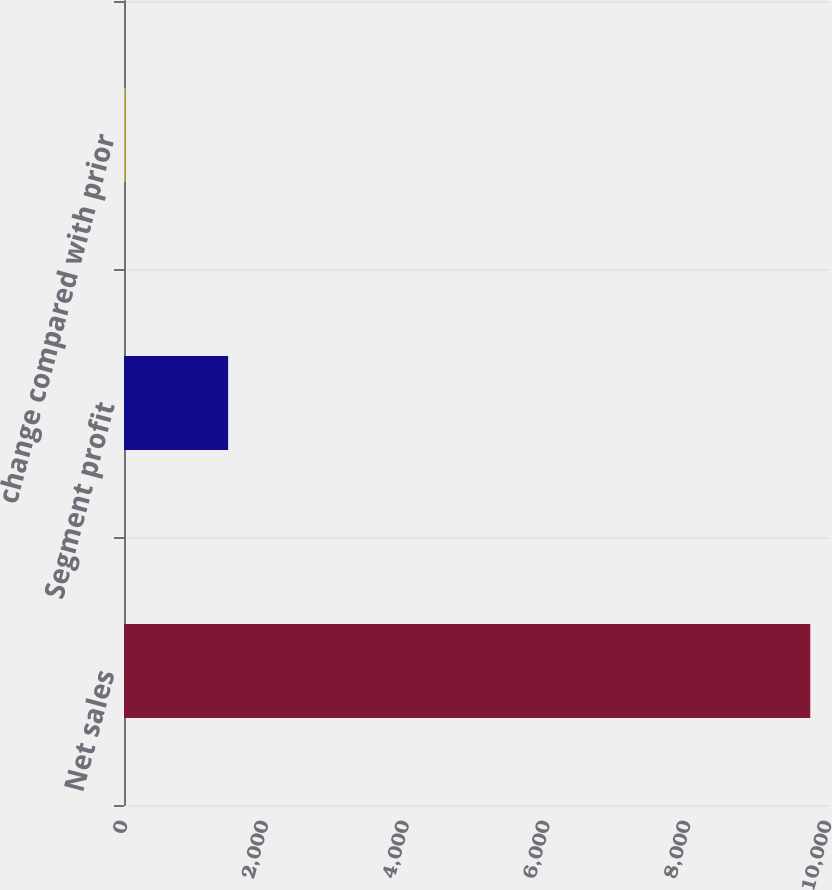Convert chart to OTSL. <chart><loc_0><loc_0><loc_500><loc_500><bar_chart><fcel>Net sales<fcel>Segment profit<fcel>change compared with prior<nl><fcel>9748<fcel>1479<fcel>21<nl></chart> 